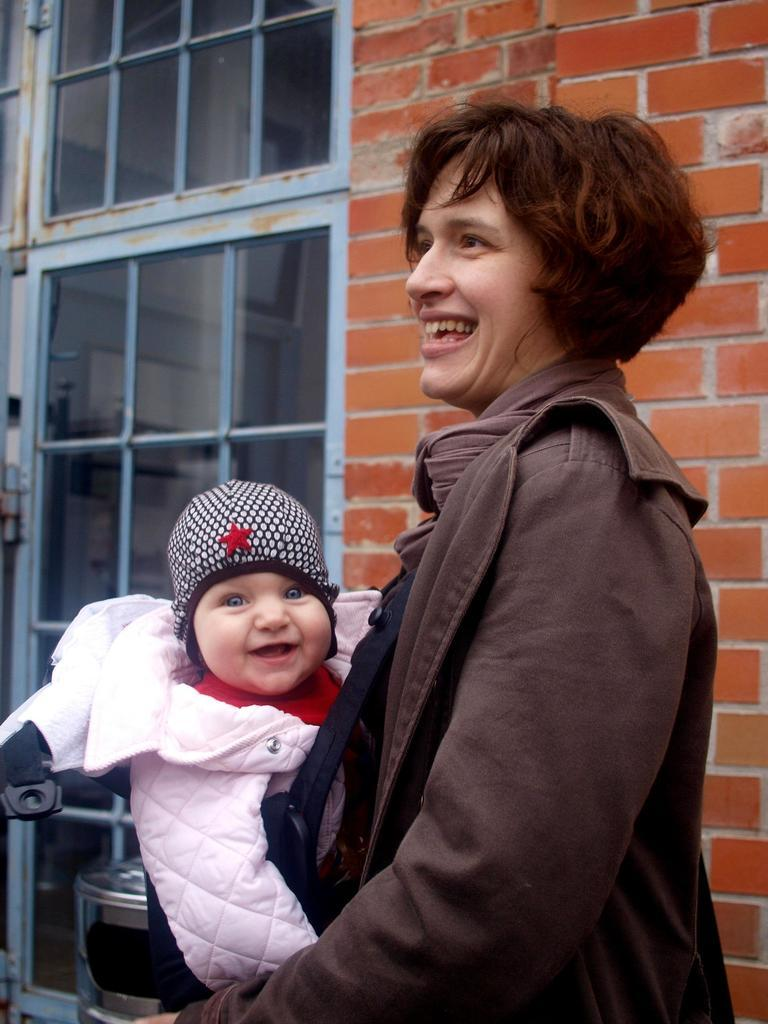What is the person in the image doing? The person is holding a baby in the image. How can you tell the person and the baby apart in terms of clothing? The person and the baby are wearing different colors. What can be seen in the background of the image? There is a brick wall and glass windows in the background of the image. How many ladybugs are crawling on the baby's clothes in the image? There are no ladybugs present in the image. What type of exchange is taking place between the person and the baby in the image? There is no exchange taking place between the person and the baby in the image; the person is simply holding the baby. 